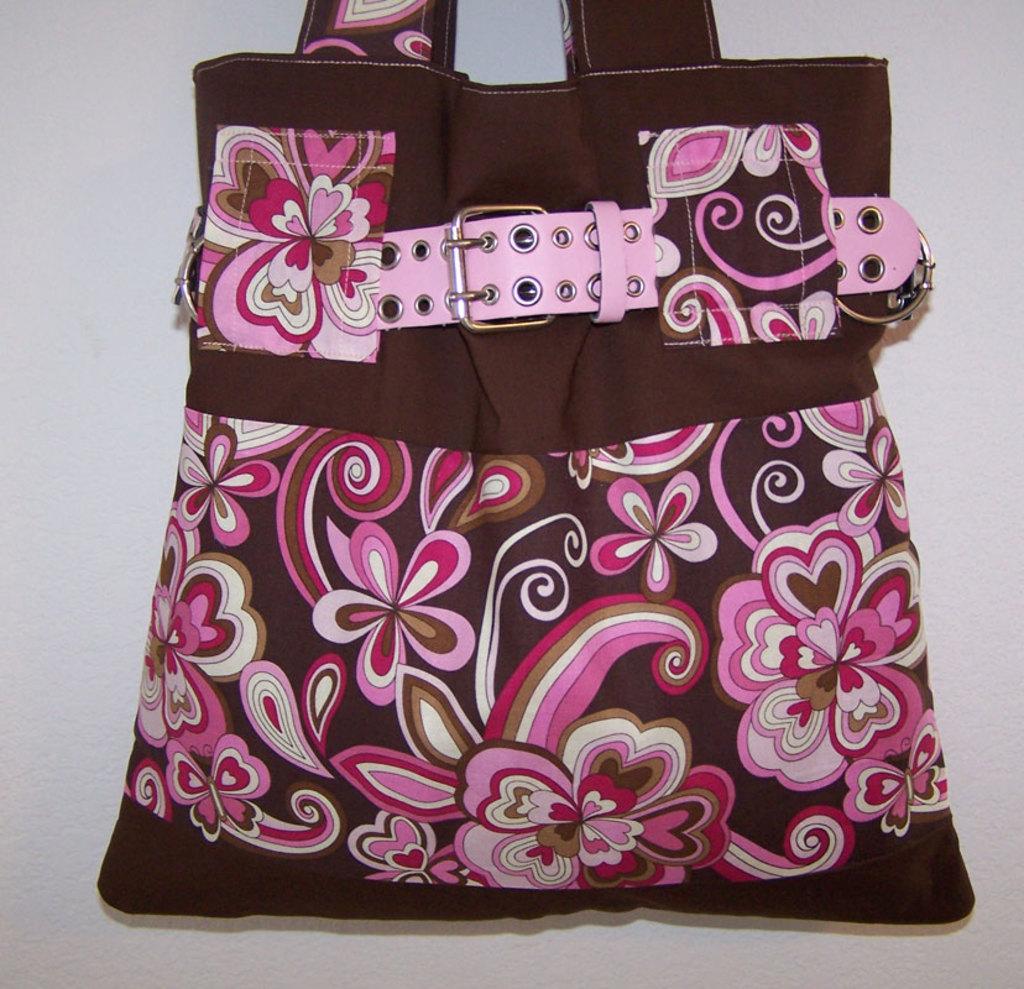Can you describe this image briefly? In this image I can see a bag. 